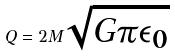Convert formula to latex. <formula><loc_0><loc_0><loc_500><loc_500>Q = 2 M \sqrt { G \pi \epsilon _ { 0 } }</formula> 